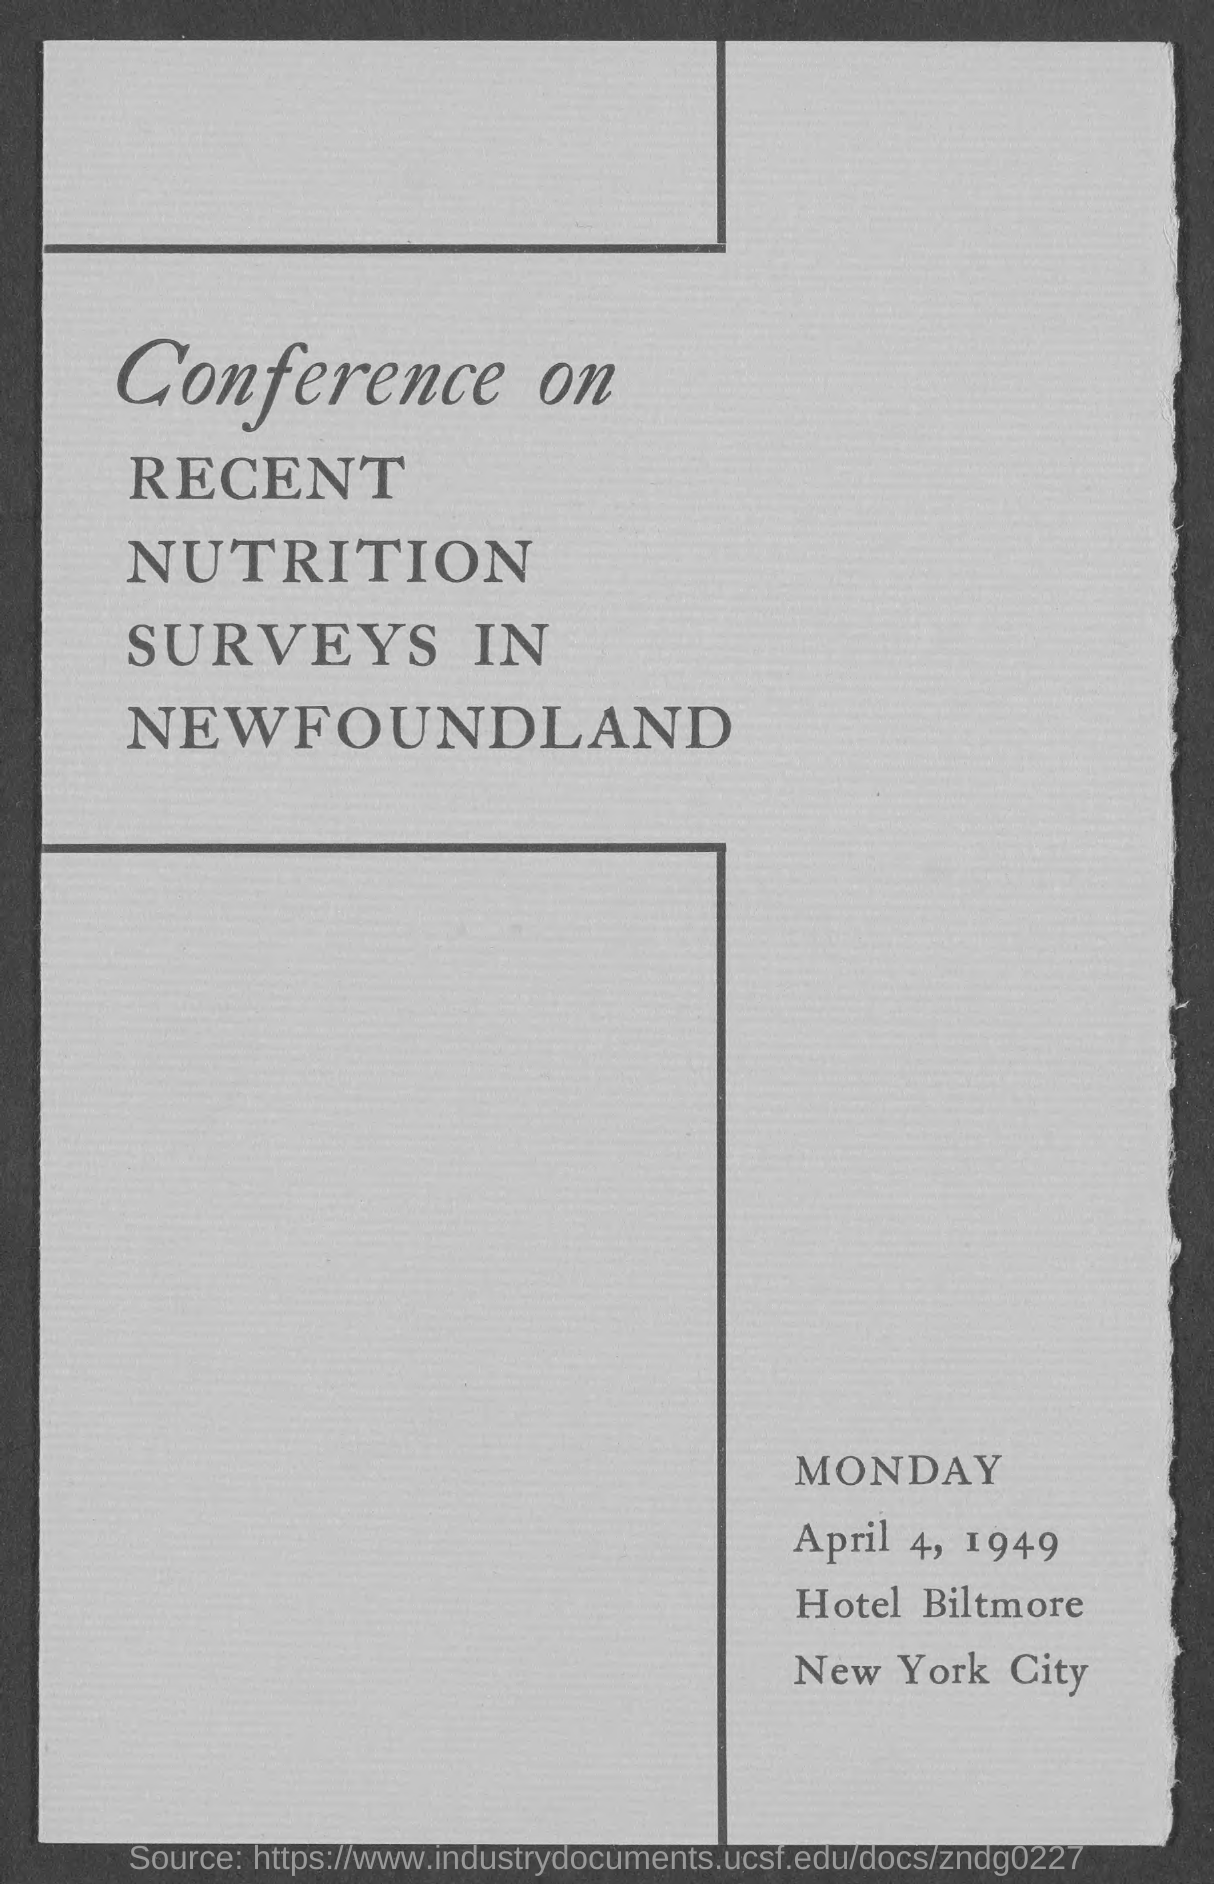Specify some key components in this picture. The document mentions Monday at the bottom-right side of the document. 